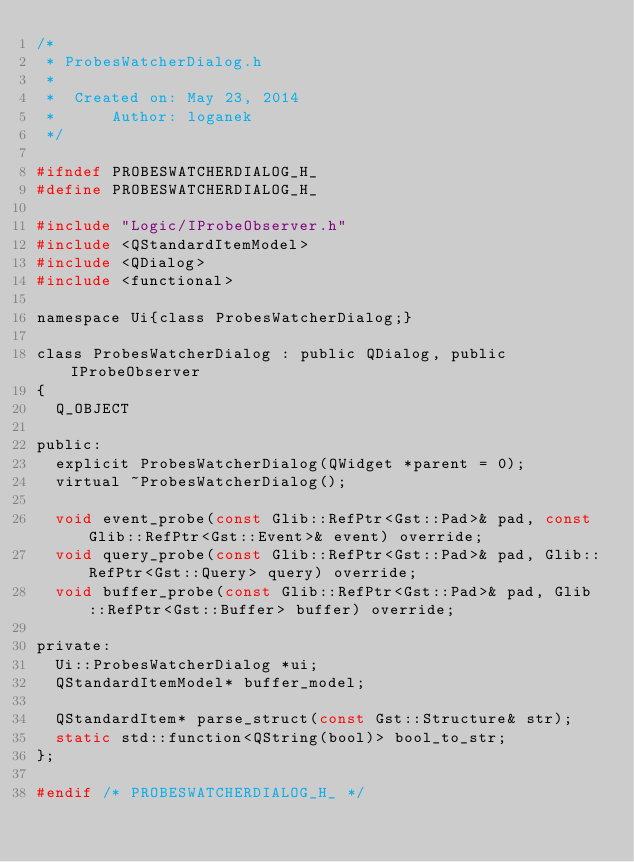Convert code to text. <code><loc_0><loc_0><loc_500><loc_500><_C_>/*
 * ProbesWatcherDialog.h
 *
 *  Created on: May 23, 2014
 *      Author: loganek
 */

#ifndef PROBESWATCHERDIALOG_H_
#define PROBESWATCHERDIALOG_H_

#include "Logic/IProbeObserver.h"
#include <QStandardItemModel>
#include <QDialog>
#include <functional>

namespace Ui{class ProbesWatcherDialog;}

class ProbesWatcherDialog : public QDialog, public IProbeObserver
{
	Q_OBJECT

public:
	explicit ProbesWatcherDialog(QWidget *parent = 0);
	virtual ~ProbesWatcherDialog();

	void event_probe(const Glib::RefPtr<Gst::Pad>& pad, const Glib::RefPtr<Gst::Event>& event) override;
	void query_probe(const Glib::RefPtr<Gst::Pad>& pad, Glib::RefPtr<Gst::Query> query) override;
	void buffer_probe(const Glib::RefPtr<Gst::Pad>& pad, Glib::RefPtr<Gst::Buffer> buffer) override;

private:
	Ui::ProbesWatcherDialog *ui;
	QStandardItemModel* buffer_model;

	QStandardItem* parse_struct(const Gst::Structure& str);
	static std::function<QString(bool)> bool_to_str;
};

#endif /* PROBESWATCHERDIALOG_H_ */
</code> 